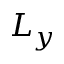Convert formula to latex. <formula><loc_0><loc_0><loc_500><loc_500>L _ { y }</formula> 